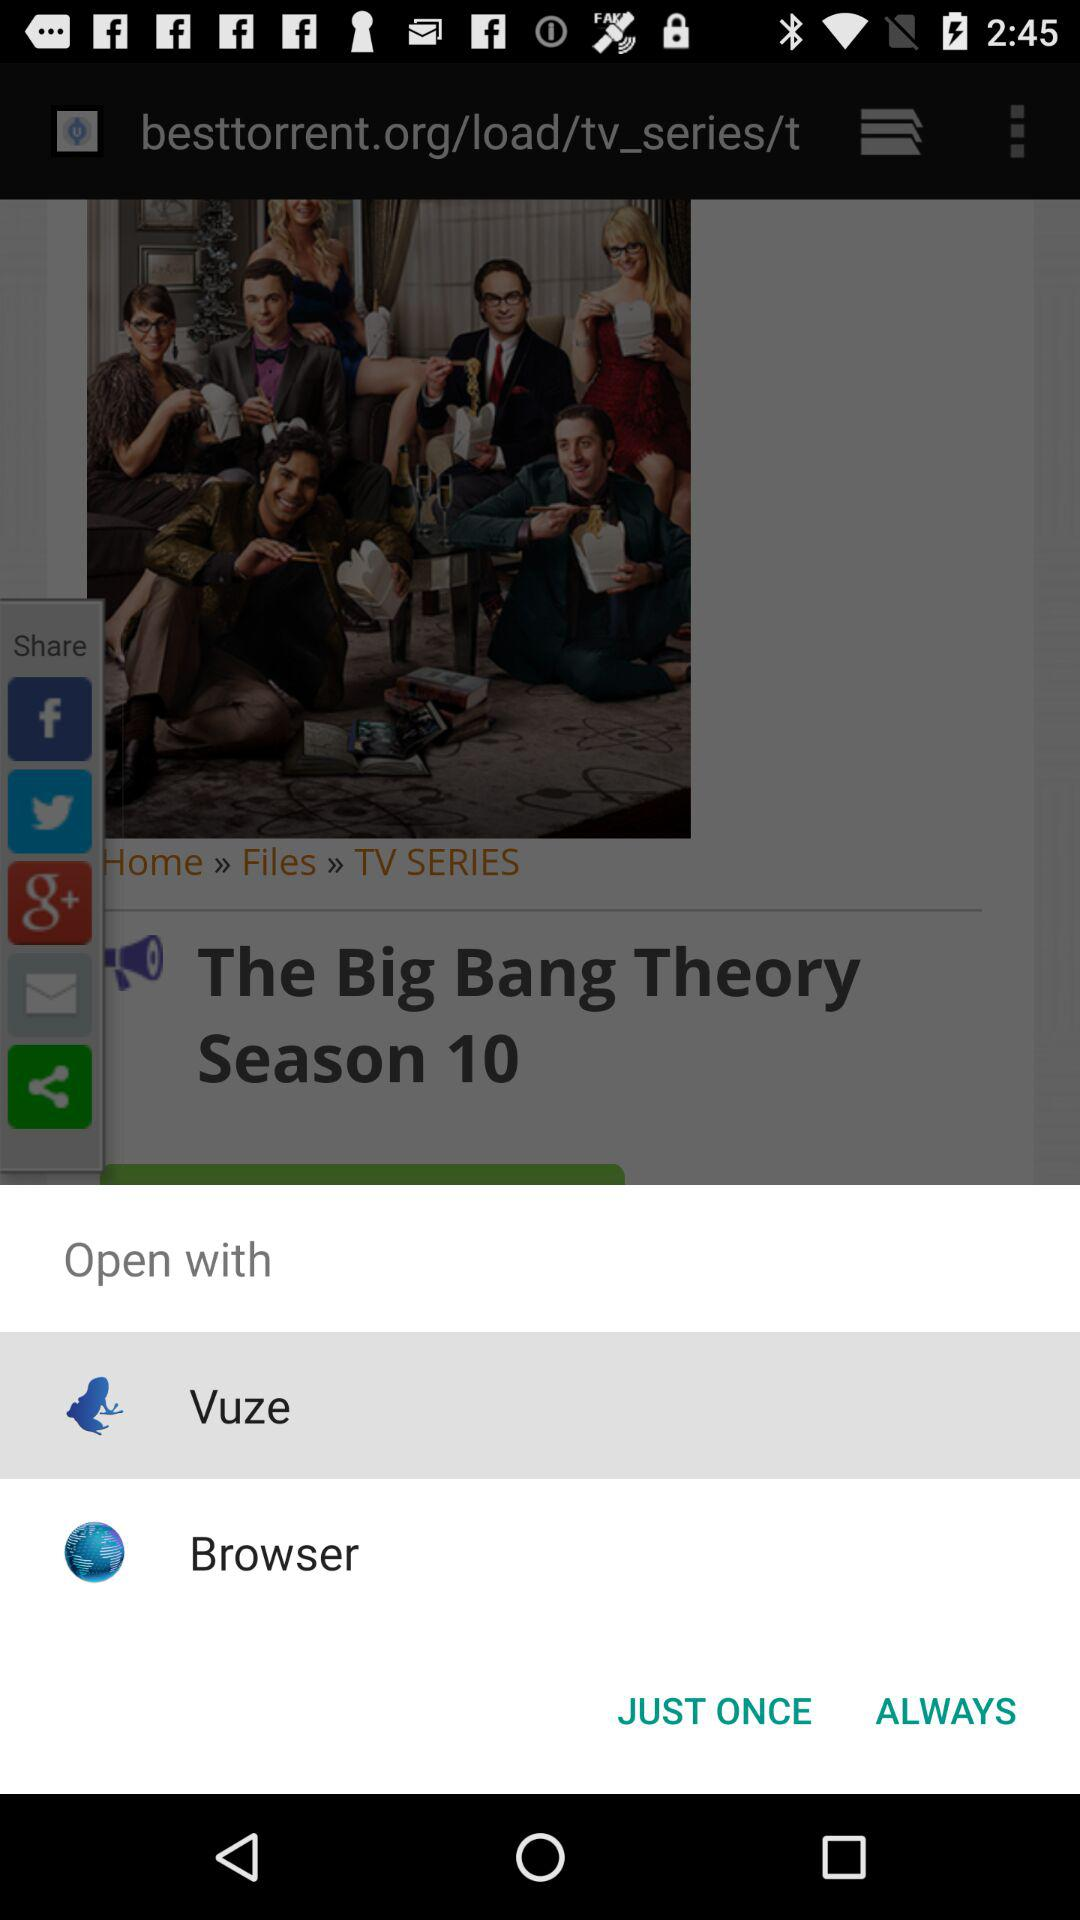Which application can I use to open the content? You can use "Vuze" and "Browser" to open the content. 